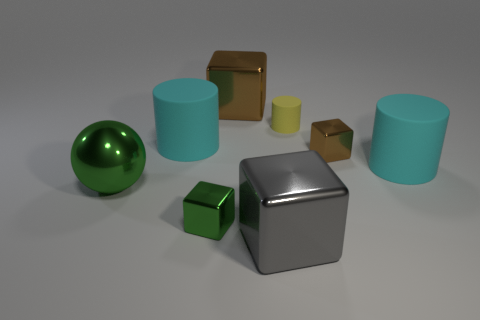Is the shape of the tiny object on the left side of the yellow matte thing the same as the cyan rubber thing to the right of the big brown metallic object? While both objects mentioned—the tiny one on the left side of the yellow matte object and the cyan one to the right of the big brown metallic object—share a basic cube shape, upon closer inspection, there are subtle differences in their form, proportions, and texture that distinguish them from each other. 